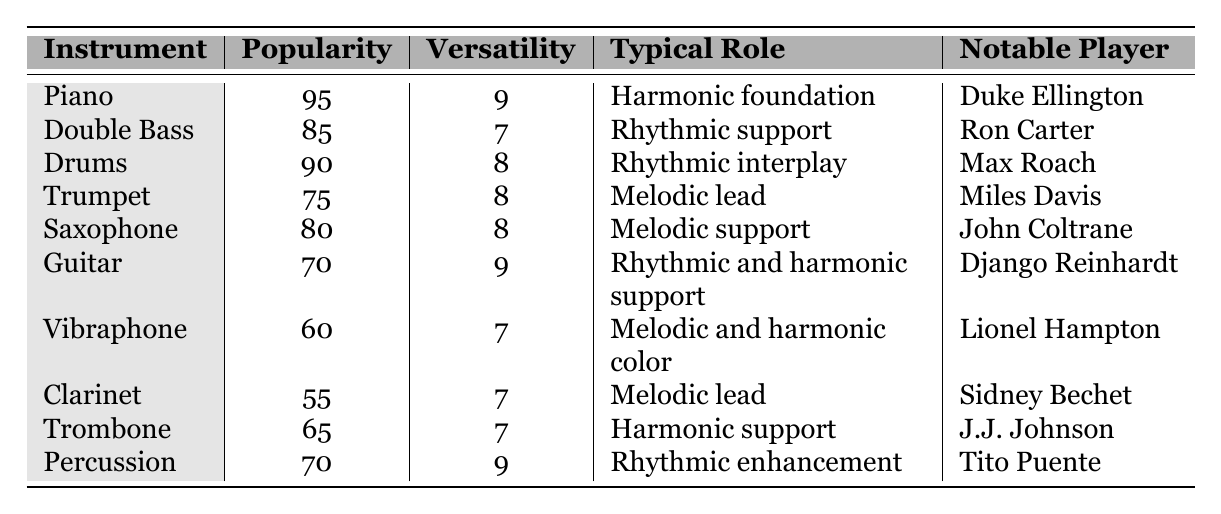What is the most popular instrument featured in jazz accompaniments for tap dance shows? The table shows that the Piano has the highest popularity score of 95 among all listed instruments.
Answer: Piano Which instrument has a typical role as "Melodic lead"? Referring to the table, the Trumpet and the Clarinet both have "Melodic lead" as their typical role.
Answer: Trumpet and Clarinet What is the average versatility of the instruments listed? To find the average, sum the versatility scores (9 + 7 + 8 + 8 + 8 + 9 + 7 + 7 + 7 + 9) which equals 78. Then divide by the number of instruments (10), resulting in an average versatility of 7.8.
Answer: 7.8 Is the Double Bass more popular than the Guitar? The popularity of the Double Bass is 85, while the Guitar has a popularity of 70. Since 85 is greater than 70, the statement is true.
Answer: Yes Which instrument has the lowest popularity and what is its notable player? The Vibraphone has the lowest popularity score of 60, and its notable player is Lionel Hampton.
Answer: Vibraphone; Lionel Hampton What is the difference in popularity between the Drums and the Trombone? The popularity of Drums is 90, and the Trombone's popularity is 65. The difference is calculated as 90 - 65 = 25.
Answer: 25 Which instrument has both high versatility and popularity? The instruments that have high versatility (8 or more) and popularity (80 or more) include Piano (95 popularity, 9 versatility) and Drums (90 popularity, 8 versatility).
Answer: Piano and Drums Name an instrument that provides rhythmic enhancement and its notable player. The Percussion is noted for its role in "Rhythmic enhancement," with its notable player being Tito Puente.
Answer: Percussion; Tito Puente If you combine the popularity scores of the Piano and the Trumpet, what total do you get? The popularity of the Piano is 95 and the Trumpet is 75. Adding these together gives 95 + 75 = 170.
Answer: 170 Which instrument is more versatile: the Vibraphone or the Clarinet? The Vibraphone has a versatility score of 7, while the Clarinet also has a versatility score of 7. Therefore, neither is more versatile as they are equal.
Answer: Neither is more versatile; both are equal 